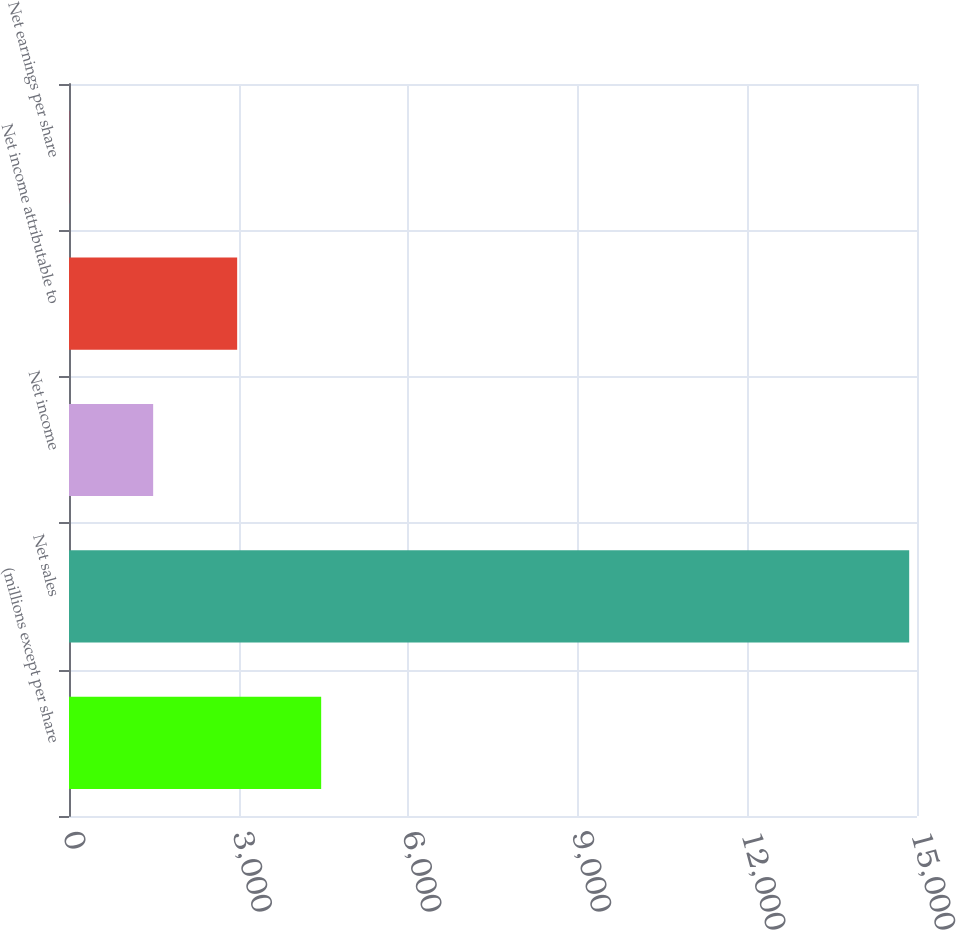Convert chart. <chart><loc_0><loc_0><loc_500><loc_500><bar_chart><fcel>(millions except per share<fcel>Net sales<fcel>Net income<fcel>Net income attributable to<fcel>Net earnings per share<nl><fcel>4460.54<fcel>14862<fcel>1488.7<fcel>2974.62<fcel>2.78<nl></chart> 